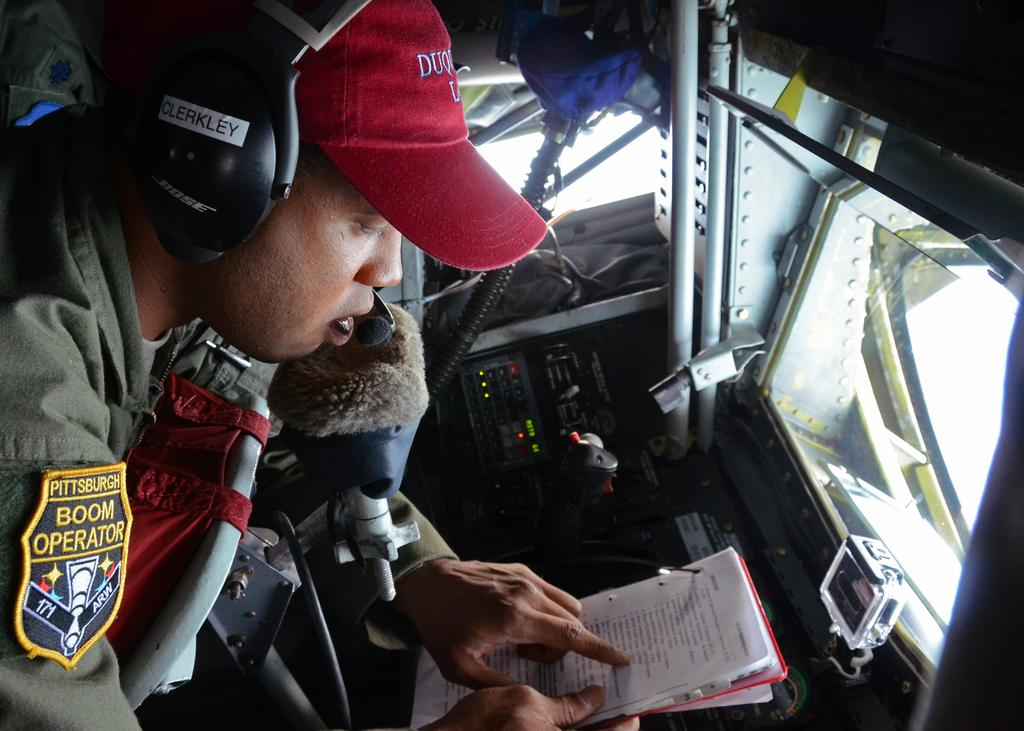What is the main subject of the image? The main subject of the image is an airplane. Can you describe the person inside the airplane? The person is wearing headphones and holding a book. What might the meters in the image be used for? The meters in the image might be used to monitor the airplane's performance or status. What other objects are present in the image? There are other objects present in the image, but their specific details are not mentioned in the provided facts. What type of wool is being used to knit a sweater for dad in the image? There is no wool or sweater being knitted for dad in the image; it depicts an airplane with a person inside. 